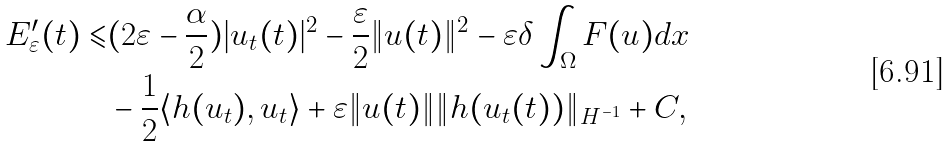<formula> <loc_0><loc_0><loc_500><loc_500>E ^ { \prime } _ { \varepsilon } ( t ) \leqslant & ( 2 \varepsilon - \frac { \alpha } { 2 } ) | u _ { t } ( t ) | ^ { 2 } - \frac { \varepsilon } { 2 } \| u ( t ) \| ^ { 2 } - \varepsilon \delta \int _ { \Omega } F ( u ) d x \\ & - \frac { 1 } { 2 } \langle h ( u _ { t } ) , u _ { t } \rangle + \varepsilon \| u ( t ) \| \| h ( u _ { t } ( t ) ) \| _ { H ^ { - 1 } } + C ,</formula> 